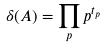Convert formula to latex. <formula><loc_0><loc_0><loc_500><loc_500>\delta ( A ) = \prod _ { p } p ^ { t _ { p } }</formula> 